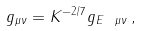<formula> <loc_0><loc_0><loc_500><loc_500>g _ { \mu \nu } = K ^ { - 2 / 7 } g _ { E \ \mu \nu } \, ,</formula> 